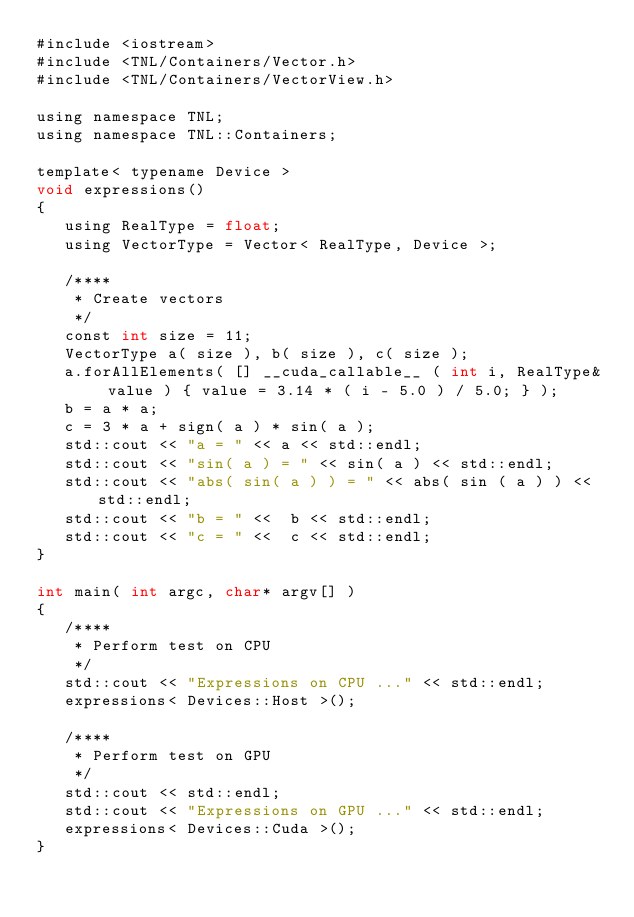<code> <loc_0><loc_0><loc_500><loc_500><_Cuda_>#include <iostream>
#include <TNL/Containers/Vector.h>
#include <TNL/Containers/VectorView.h>

using namespace TNL;
using namespace TNL::Containers;

template< typename Device >
void expressions()
{
   using RealType = float;
   using VectorType = Vector< RealType, Device >;

   /****
    * Create vectors
    */
   const int size = 11;
   VectorType a( size ), b( size ), c( size );
   a.forAllElements( [] __cuda_callable__ ( int i, RealType& value ) { value = 3.14 * ( i - 5.0 ) / 5.0; } );
   b = a * a;
   c = 3 * a + sign( a ) * sin( a );
   std::cout << "a = " << a << std::endl;
   std::cout << "sin( a ) = " << sin( a ) << std::endl;
   std::cout << "abs( sin( a ) ) = " << abs( sin ( a ) ) << std::endl;
   std::cout << "b = " <<  b << std::endl;
   std::cout << "c = " <<  c << std::endl;
}

int main( int argc, char* argv[] )
{
   /****
    * Perform test on CPU
    */
   std::cout << "Expressions on CPU ..." << std::endl;
   expressions< Devices::Host >();

   /****
    * Perform test on GPU
    */
   std::cout << std::endl;
   std::cout << "Expressions on GPU ..." << std::endl;
   expressions< Devices::Cuda >();
}


</code> 